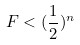<formula> <loc_0><loc_0><loc_500><loc_500>F < ( \frac { 1 } { 2 } ) ^ { n }</formula> 